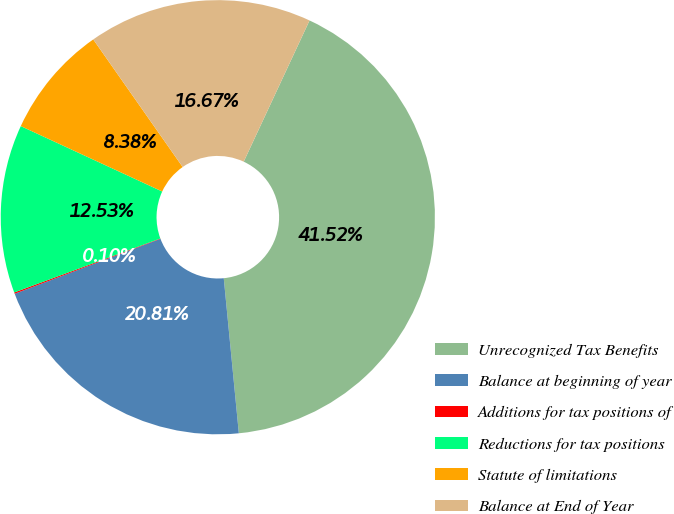Convert chart to OTSL. <chart><loc_0><loc_0><loc_500><loc_500><pie_chart><fcel>Unrecognized Tax Benefits<fcel>Balance at beginning of year<fcel>Additions for tax positions of<fcel>Reductions for tax positions<fcel>Statute of limitations<fcel>Balance at End of Year<nl><fcel>41.52%<fcel>20.81%<fcel>0.1%<fcel>12.53%<fcel>8.38%<fcel>16.67%<nl></chart> 